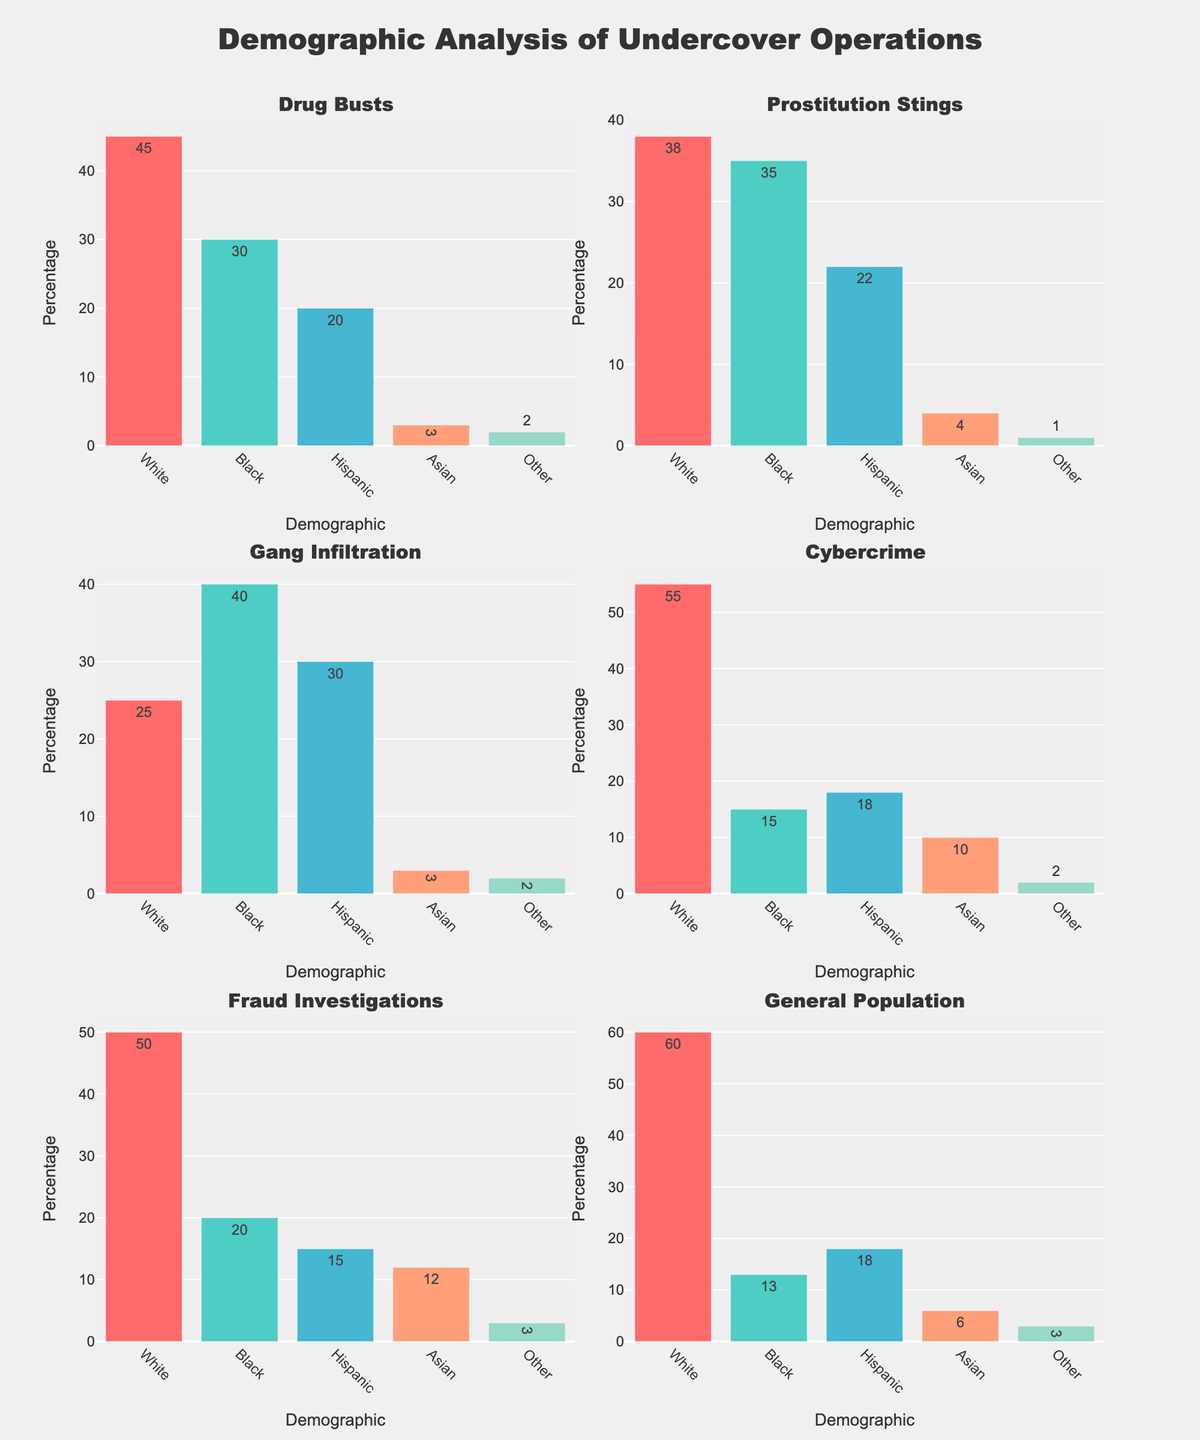What is the continent with the highest indigenous population shown in the plot? India in Asia has the highest indigenous population in the plot with 104,281,000. From the figure, we can identify the continents and see that Asia, especially India, has the tallest bar indicating the highest indigenous population.
Answer: Asia Which country in North America has the smallest indigenous population? Canada has the smallest indigenous population in North America, with 1,673,785 individuals. This can be identified as the shortest bar within the North America subplot.
Answer: Canada What is the sum of the indigenous populations in South America? The population values from South America are Brazil (896,917), Peru (7,021,271), and Bolivia (4,199,900). Adding them together: 896,917 + 7,021,271 + 4,199,900 = 12,118,088.
Answer: 12,118,088 Compare the indigenous populations of Australia and Papua New Guinea in Oceania. Which one is larger and by how much? Australia has an indigenous population of 798,400, and Papua New Guinea has 7,059,540. Papua New Guinea has a larger indigenous population than Australia. The difference is 7,059,540 - 798,400 = 6,261,140.
Answer: Papua New Guinea, 6,261,140 How does the indigenous population of Ethiopia compare to that of Kenya in Africa? Ethiopia has an indigenous population of 15,000,000, whereas Kenya has 840,000. Ethiopia’s indigenous population is larger than Kenya's by 15,000,000 - 840,000 = 14,160,000.
Answer: Ethiopia, 14,160,000 Which country in Europe has the highest indigenous population, and what is that population? Russia has the highest indigenous population in Europe, with an estimated population of 260,000. This is evident as the highest bar in the Europe subplot.
Answer: Russia, 260,000 What is the average indigenous population across all the countries listed in Asia? The population values from Asia are India (104,281,000), Philippines (14,184,000), and Indonesia (50,000,000). Summing these gives us 104,281,000 + 14,184,000 + 50,000,000 = 168,465,000. There are 3 countries, so the average is 168,465,000 / 3 = 56,155,000.
Answer: 56,155,000 Identify the country with the smallest indigenous population in the plotted data and state the population. Finland has the smallest indigenous population with 10,000 people. This is evident as the shortest bar across all subplots.
Answer: Finland, 10,000 Which continent has the most countries represented in the plot, and how many are there? North America has the most countries represented with a total of 3 countries: Canada, United States, and Mexico. This can be discerned by counting the number of bars in each subplot.
Answer: North America, 3 What is the combined indigenous population of Sweden and Finland in Europe? Sweden has an indigenous population of 20,000 and Finland has 10,000. Combining these populations: 20,000 + 10,000 = 30,000.
Answer: 30,000 